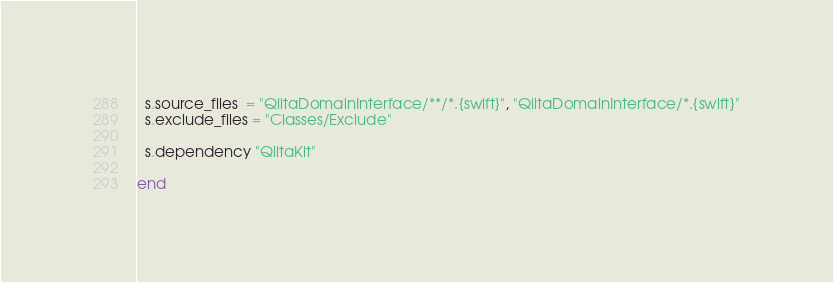<code> <loc_0><loc_0><loc_500><loc_500><_Ruby_>


  s.source_files  = "QiitaDomainInterface/**/*.{swift}", "QiitaDomainInterface/*.{swift}"
  s.exclude_files = "Classes/Exclude"

  s.dependency "QiitaKit"

end
</code> 